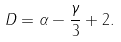Convert formula to latex. <formula><loc_0><loc_0><loc_500><loc_500>D = \alpha - \frac { \gamma } { 3 } + 2 .</formula> 